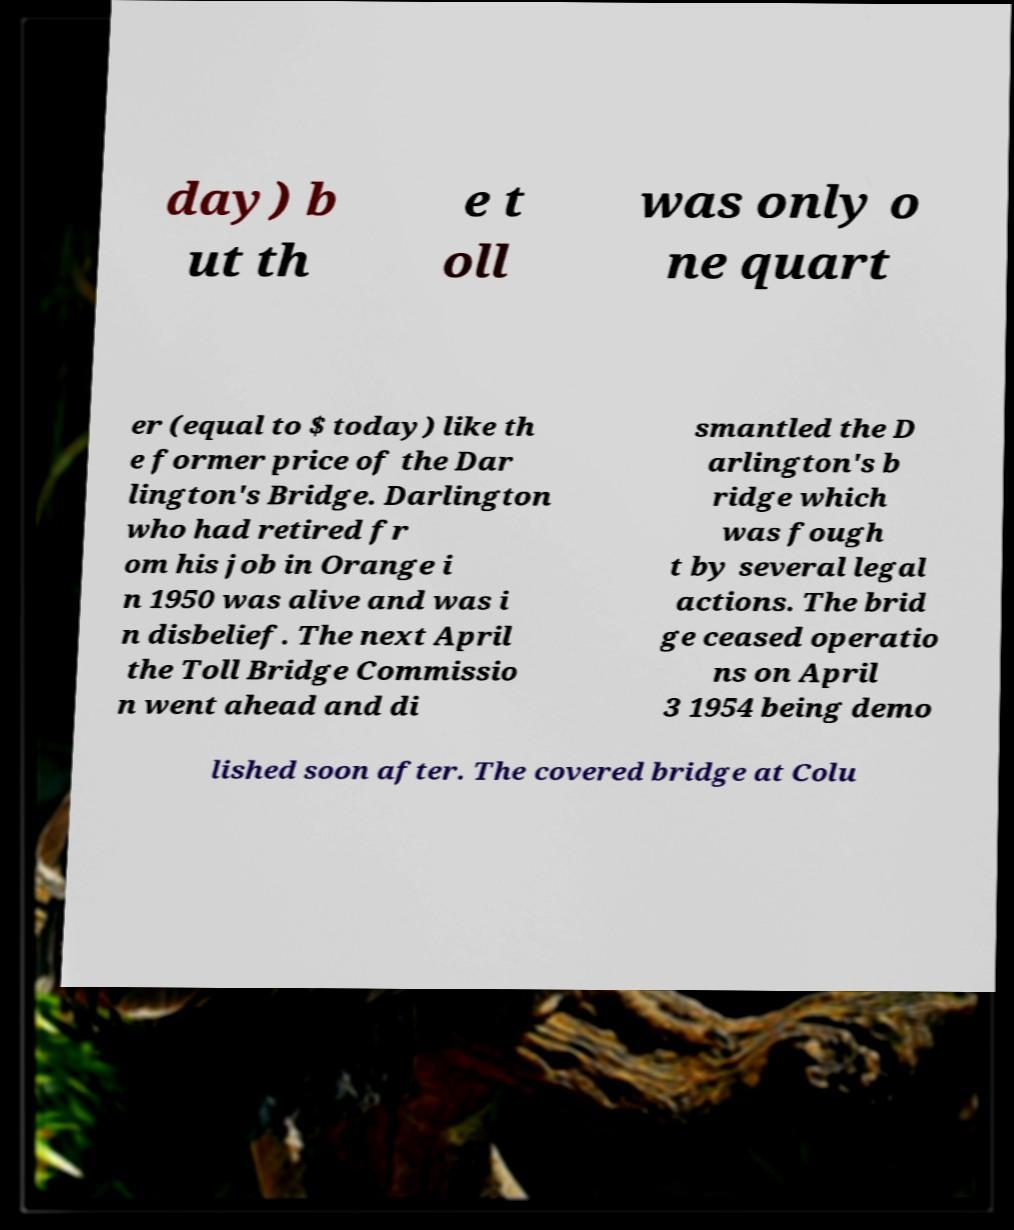Please identify and transcribe the text found in this image. day) b ut th e t oll was only o ne quart er (equal to $ today) like th e former price of the Dar lington's Bridge. Darlington who had retired fr om his job in Orange i n 1950 was alive and was i n disbelief. The next April the Toll Bridge Commissio n went ahead and di smantled the D arlington's b ridge which was fough t by several legal actions. The brid ge ceased operatio ns on April 3 1954 being demo lished soon after. The covered bridge at Colu 